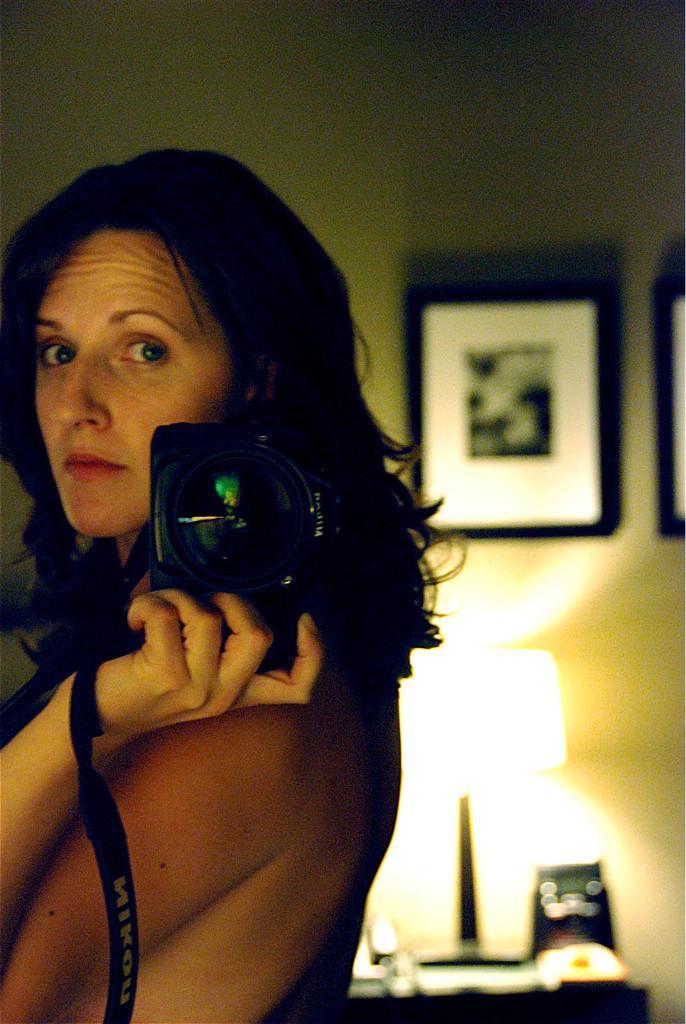How would you summarize this image in a sentence or two? She is standing and she is holding a camera. We can see the background photo frame and lamp. 